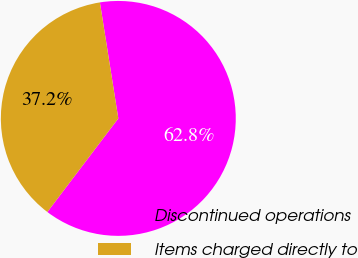Convert chart to OTSL. <chart><loc_0><loc_0><loc_500><loc_500><pie_chart><fcel>Discontinued operations<fcel>Items charged directly to<nl><fcel>62.83%<fcel>37.17%<nl></chart> 